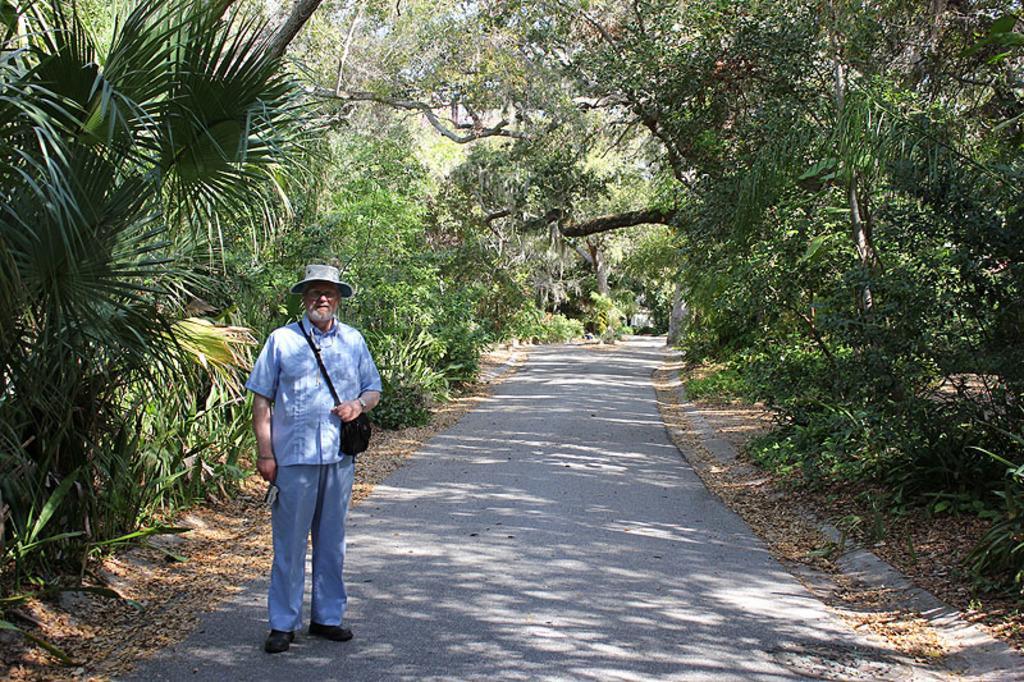In one or two sentences, can you explain what this image depicts? In this image there is a man standing on a road, on either side of the road there are trees. 